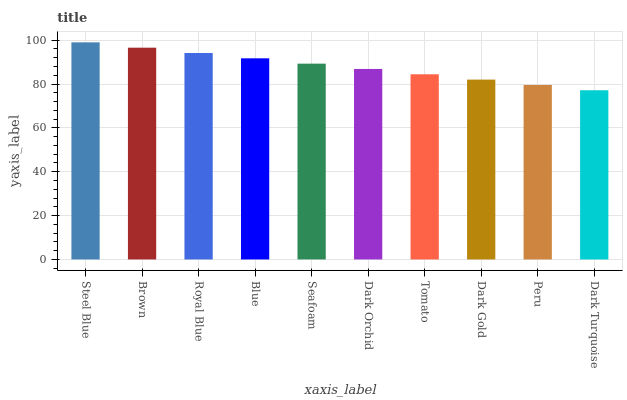Is Dark Turquoise the minimum?
Answer yes or no. Yes. Is Steel Blue the maximum?
Answer yes or no. Yes. Is Brown the minimum?
Answer yes or no. No. Is Brown the maximum?
Answer yes or no. No. Is Steel Blue greater than Brown?
Answer yes or no. Yes. Is Brown less than Steel Blue?
Answer yes or no. Yes. Is Brown greater than Steel Blue?
Answer yes or no. No. Is Steel Blue less than Brown?
Answer yes or no. No. Is Seafoam the high median?
Answer yes or no. Yes. Is Dark Orchid the low median?
Answer yes or no. Yes. Is Peru the high median?
Answer yes or no. No. Is Seafoam the low median?
Answer yes or no. No. 